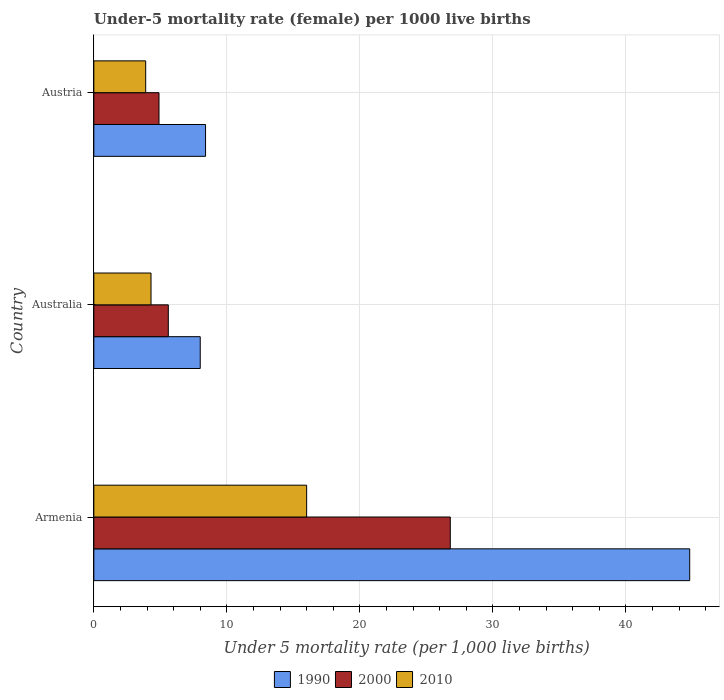How many different coloured bars are there?
Make the answer very short. 3. How many groups of bars are there?
Ensure brevity in your answer.  3. How many bars are there on the 2nd tick from the top?
Ensure brevity in your answer.  3. How many bars are there on the 2nd tick from the bottom?
Ensure brevity in your answer.  3. What is the label of the 3rd group of bars from the top?
Your answer should be very brief. Armenia. Across all countries, what is the maximum under-five mortality rate in 1990?
Ensure brevity in your answer.  44.8. In which country was the under-five mortality rate in 2000 maximum?
Give a very brief answer. Armenia. What is the total under-five mortality rate in 2010 in the graph?
Make the answer very short. 24.2. What is the difference between the under-five mortality rate in 2010 in Austria and the under-five mortality rate in 1990 in Australia?
Your response must be concise. -4.1. What is the average under-five mortality rate in 2000 per country?
Ensure brevity in your answer.  12.43. In how many countries, is the under-five mortality rate in 2000 greater than 22 ?
Your response must be concise. 1. What is the ratio of the under-five mortality rate in 2000 in Australia to that in Austria?
Provide a succinct answer. 1.14. What is the difference between the highest and the lowest under-five mortality rate in 1990?
Your answer should be compact. 36.8. In how many countries, is the under-five mortality rate in 2000 greater than the average under-five mortality rate in 2000 taken over all countries?
Offer a very short reply. 1. Is the sum of the under-five mortality rate in 2010 in Armenia and Austria greater than the maximum under-five mortality rate in 1990 across all countries?
Offer a terse response. No. What does the 1st bar from the bottom in Australia represents?
Provide a succinct answer. 1990. How many bars are there?
Offer a very short reply. 9. Are all the bars in the graph horizontal?
Provide a short and direct response. Yes. What is the difference between two consecutive major ticks on the X-axis?
Ensure brevity in your answer.  10. Are the values on the major ticks of X-axis written in scientific E-notation?
Give a very brief answer. No. Does the graph contain any zero values?
Provide a succinct answer. No. Does the graph contain grids?
Ensure brevity in your answer.  Yes. How many legend labels are there?
Make the answer very short. 3. How are the legend labels stacked?
Ensure brevity in your answer.  Horizontal. What is the title of the graph?
Keep it short and to the point. Under-5 mortality rate (female) per 1000 live births. Does "1967" appear as one of the legend labels in the graph?
Keep it short and to the point. No. What is the label or title of the X-axis?
Ensure brevity in your answer.  Under 5 mortality rate (per 1,0 live births). What is the label or title of the Y-axis?
Your answer should be very brief. Country. What is the Under 5 mortality rate (per 1,000 live births) of 1990 in Armenia?
Offer a very short reply. 44.8. What is the Under 5 mortality rate (per 1,000 live births) of 2000 in Armenia?
Offer a very short reply. 26.8. What is the Under 5 mortality rate (per 1,000 live births) of 1990 in Australia?
Your answer should be very brief. 8. What is the Under 5 mortality rate (per 1,000 live births) of 2000 in Australia?
Provide a succinct answer. 5.6. What is the Under 5 mortality rate (per 1,000 live births) in 2010 in Australia?
Ensure brevity in your answer.  4.3. Across all countries, what is the maximum Under 5 mortality rate (per 1,000 live births) of 1990?
Provide a short and direct response. 44.8. Across all countries, what is the maximum Under 5 mortality rate (per 1,000 live births) of 2000?
Your answer should be very brief. 26.8. Across all countries, what is the maximum Under 5 mortality rate (per 1,000 live births) in 2010?
Your answer should be very brief. 16. Across all countries, what is the minimum Under 5 mortality rate (per 1,000 live births) of 2000?
Make the answer very short. 4.9. Across all countries, what is the minimum Under 5 mortality rate (per 1,000 live births) of 2010?
Make the answer very short. 3.9. What is the total Under 5 mortality rate (per 1,000 live births) of 1990 in the graph?
Give a very brief answer. 61.2. What is the total Under 5 mortality rate (per 1,000 live births) of 2000 in the graph?
Provide a short and direct response. 37.3. What is the total Under 5 mortality rate (per 1,000 live births) of 2010 in the graph?
Your response must be concise. 24.2. What is the difference between the Under 5 mortality rate (per 1,000 live births) of 1990 in Armenia and that in Australia?
Keep it short and to the point. 36.8. What is the difference between the Under 5 mortality rate (per 1,000 live births) of 2000 in Armenia and that in Australia?
Your answer should be compact. 21.2. What is the difference between the Under 5 mortality rate (per 1,000 live births) in 1990 in Armenia and that in Austria?
Ensure brevity in your answer.  36.4. What is the difference between the Under 5 mortality rate (per 1,000 live births) of 2000 in Armenia and that in Austria?
Provide a short and direct response. 21.9. What is the difference between the Under 5 mortality rate (per 1,000 live births) of 1990 in Australia and that in Austria?
Your answer should be compact. -0.4. What is the difference between the Under 5 mortality rate (per 1,000 live births) of 1990 in Armenia and the Under 5 mortality rate (per 1,000 live births) of 2000 in Australia?
Your answer should be very brief. 39.2. What is the difference between the Under 5 mortality rate (per 1,000 live births) in 1990 in Armenia and the Under 5 mortality rate (per 1,000 live births) in 2010 in Australia?
Your response must be concise. 40.5. What is the difference between the Under 5 mortality rate (per 1,000 live births) of 1990 in Armenia and the Under 5 mortality rate (per 1,000 live births) of 2000 in Austria?
Ensure brevity in your answer.  39.9. What is the difference between the Under 5 mortality rate (per 1,000 live births) in 1990 in Armenia and the Under 5 mortality rate (per 1,000 live births) in 2010 in Austria?
Ensure brevity in your answer.  40.9. What is the difference between the Under 5 mortality rate (per 1,000 live births) in 2000 in Armenia and the Under 5 mortality rate (per 1,000 live births) in 2010 in Austria?
Provide a succinct answer. 22.9. What is the difference between the Under 5 mortality rate (per 1,000 live births) in 1990 in Australia and the Under 5 mortality rate (per 1,000 live births) in 2000 in Austria?
Ensure brevity in your answer.  3.1. What is the difference between the Under 5 mortality rate (per 1,000 live births) of 2000 in Australia and the Under 5 mortality rate (per 1,000 live births) of 2010 in Austria?
Make the answer very short. 1.7. What is the average Under 5 mortality rate (per 1,000 live births) in 1990 per country?
Provide a short and direct response. 20.4. What is the average Under 5 mortality rate (per 1,000 live births) of 2000 per country?
Offer a terse response. 12.43. What is the average Under 5 mortality rate (per 1,000 live births) in 2010 per country?
Your response must be concise. 8.07. What is the difference between the Under 5 mortality rate (per 1,000 live births) in 1990 and Under 5 mortality rate (per 1,000 live births) in 2000 in Armenia?
Offer a terse response. 18. What is the difference between the Under 5 mortality rate (per 1,000 live births) of 1990 and Under 5 mortality rate (per 1,000 live births) of 2010 in Armenia?
Your response must be concise. 28.8. What is the difference between the Under 5 mortality rate (per 1,000 live births) of 1990 and Under 5 mortality rate (per 1,000 live births) of 2010 in Australia?
Offer a terse response. 3.7. What is the difference between the Under 5 mortality rate (per 1,000 live births) in 1990 and Under 5 mortality rate (per 1,000 live births) in 2000 in Austria?
Keep it short and to the point. 3.5. What is the difference between the Under 5 mortality rate (per 1,000 live births) in 1990 and Under 5 mortality rate (per 1,000 live births) in 2010 in Austria?
Offer a terse response. 4.5. What is the ratio of the Under 5 mortality rate (per 1,000 live births) in 2000 in Armenia to that in Australia?
Offer a terse response. 4.79. What is the ratio of the Under 5 mortality rate (per 1,000 live births) of 2010 in Armenia to that in Australia?
Offer a terse response. 3.72. What is the ratio of the Under 5 mortality rate (per 1,000 live births) in 1990 in Armenia to that in Austria?
Give a very brief answer. 5.33. What is the ratio of the Under 5 mortality rate (per 1,000 live births) in 2000 in Armenia to that in Austria?
Keep it short and to the point. 5.47. What is the ratio of the Under 5 mortality rate (per 1,000 live births) of 2010 in Armenia to that in Austria?
Provide a short and direct response. 4.1. What is the ratio of the Under 5 mortality rate (per 1,000 live births) of 2010 in Australia to that in Austria?
Provide a succinct answer. 1.1. What is the difference between the highest and the second highest Under 5 mortality rate (per 1,000 live births) of 1990?
Your response must be concise. 36.4. What is the difference between the highest and the second highest Under 5 mortality rate (per 1,000 live births) of 2000?
Keep it short and to the point. 21.2. What is the difference between the highest and the second highest Under 5 mortality rate (per 1,000 live births) in 2010?
Make the answer very short. 11.7. What is the difference between the highest and the lowest Under 5 mortality rate (per 1,000 live births) in 1990?
Provide a succinct answer. 36.8. What is the difference between the highest and the lowest Under 5 mortality rate (per 1,000 live births) of 2000?
Make the answer very short. 21.9. 